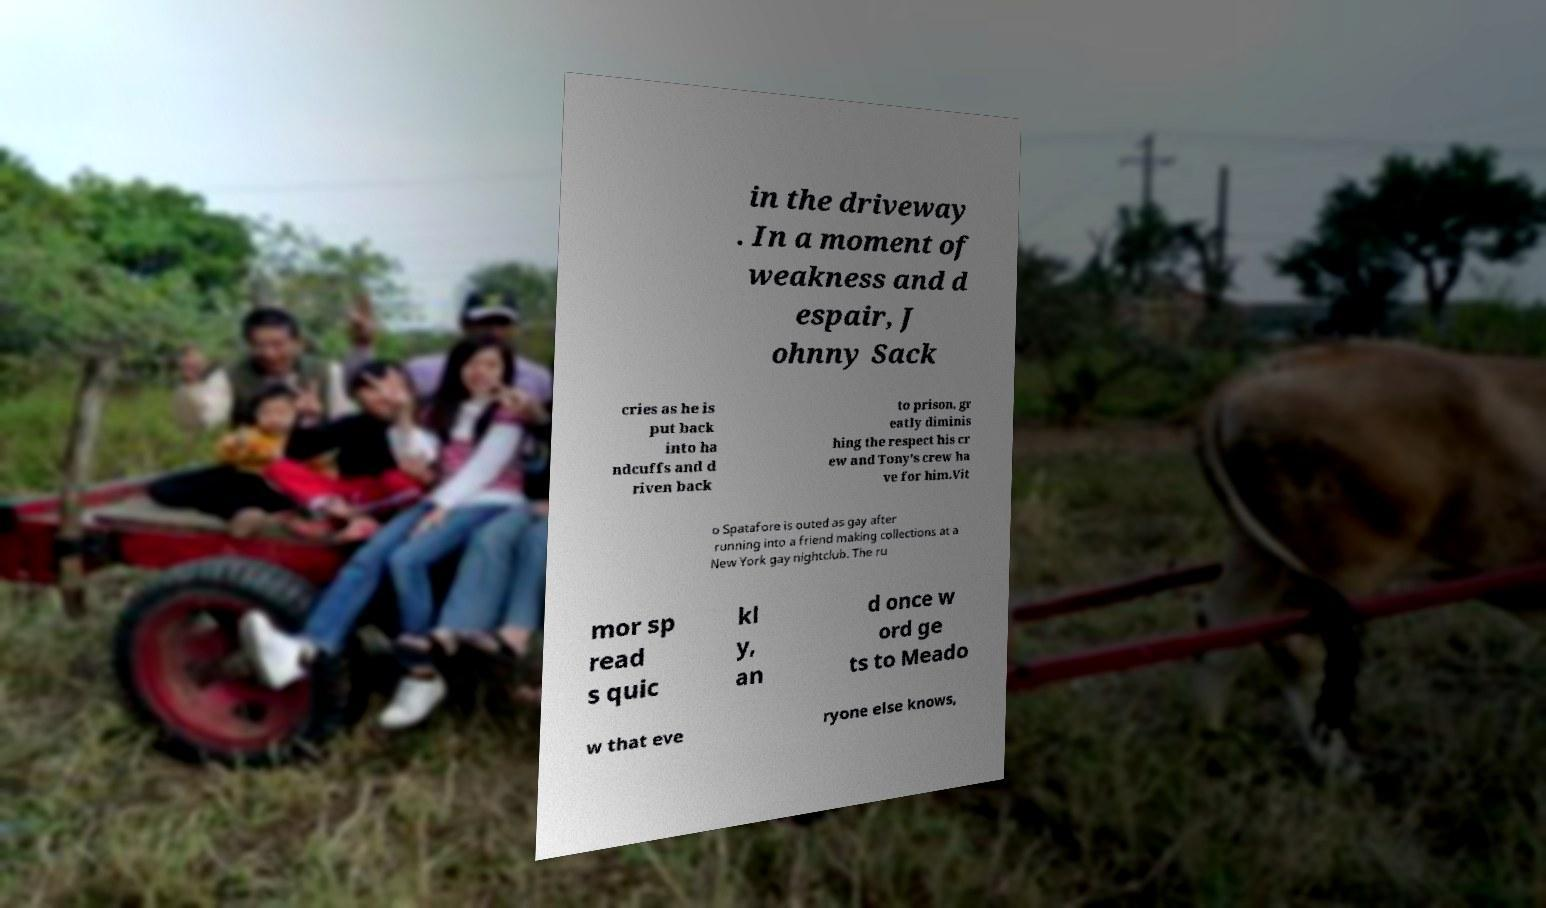There's text embedded in this image that I need extracted. Can you transcribe it verbatim? in the driveway . In a moment of weakness and d espair, J ohnny Sack cries as he is put back into ha ndcuffs and d riven back to prison, gr eatly diminis hing the respect his cr ew and Tony's crew ha ve for him.Vit o Spatafore is outed as gay after running into a friend making collections at a New York gay nightclub. The ru mor sp read s quic kl y, an d once w ord ge ts to Meado w that eve ryone else knows, 